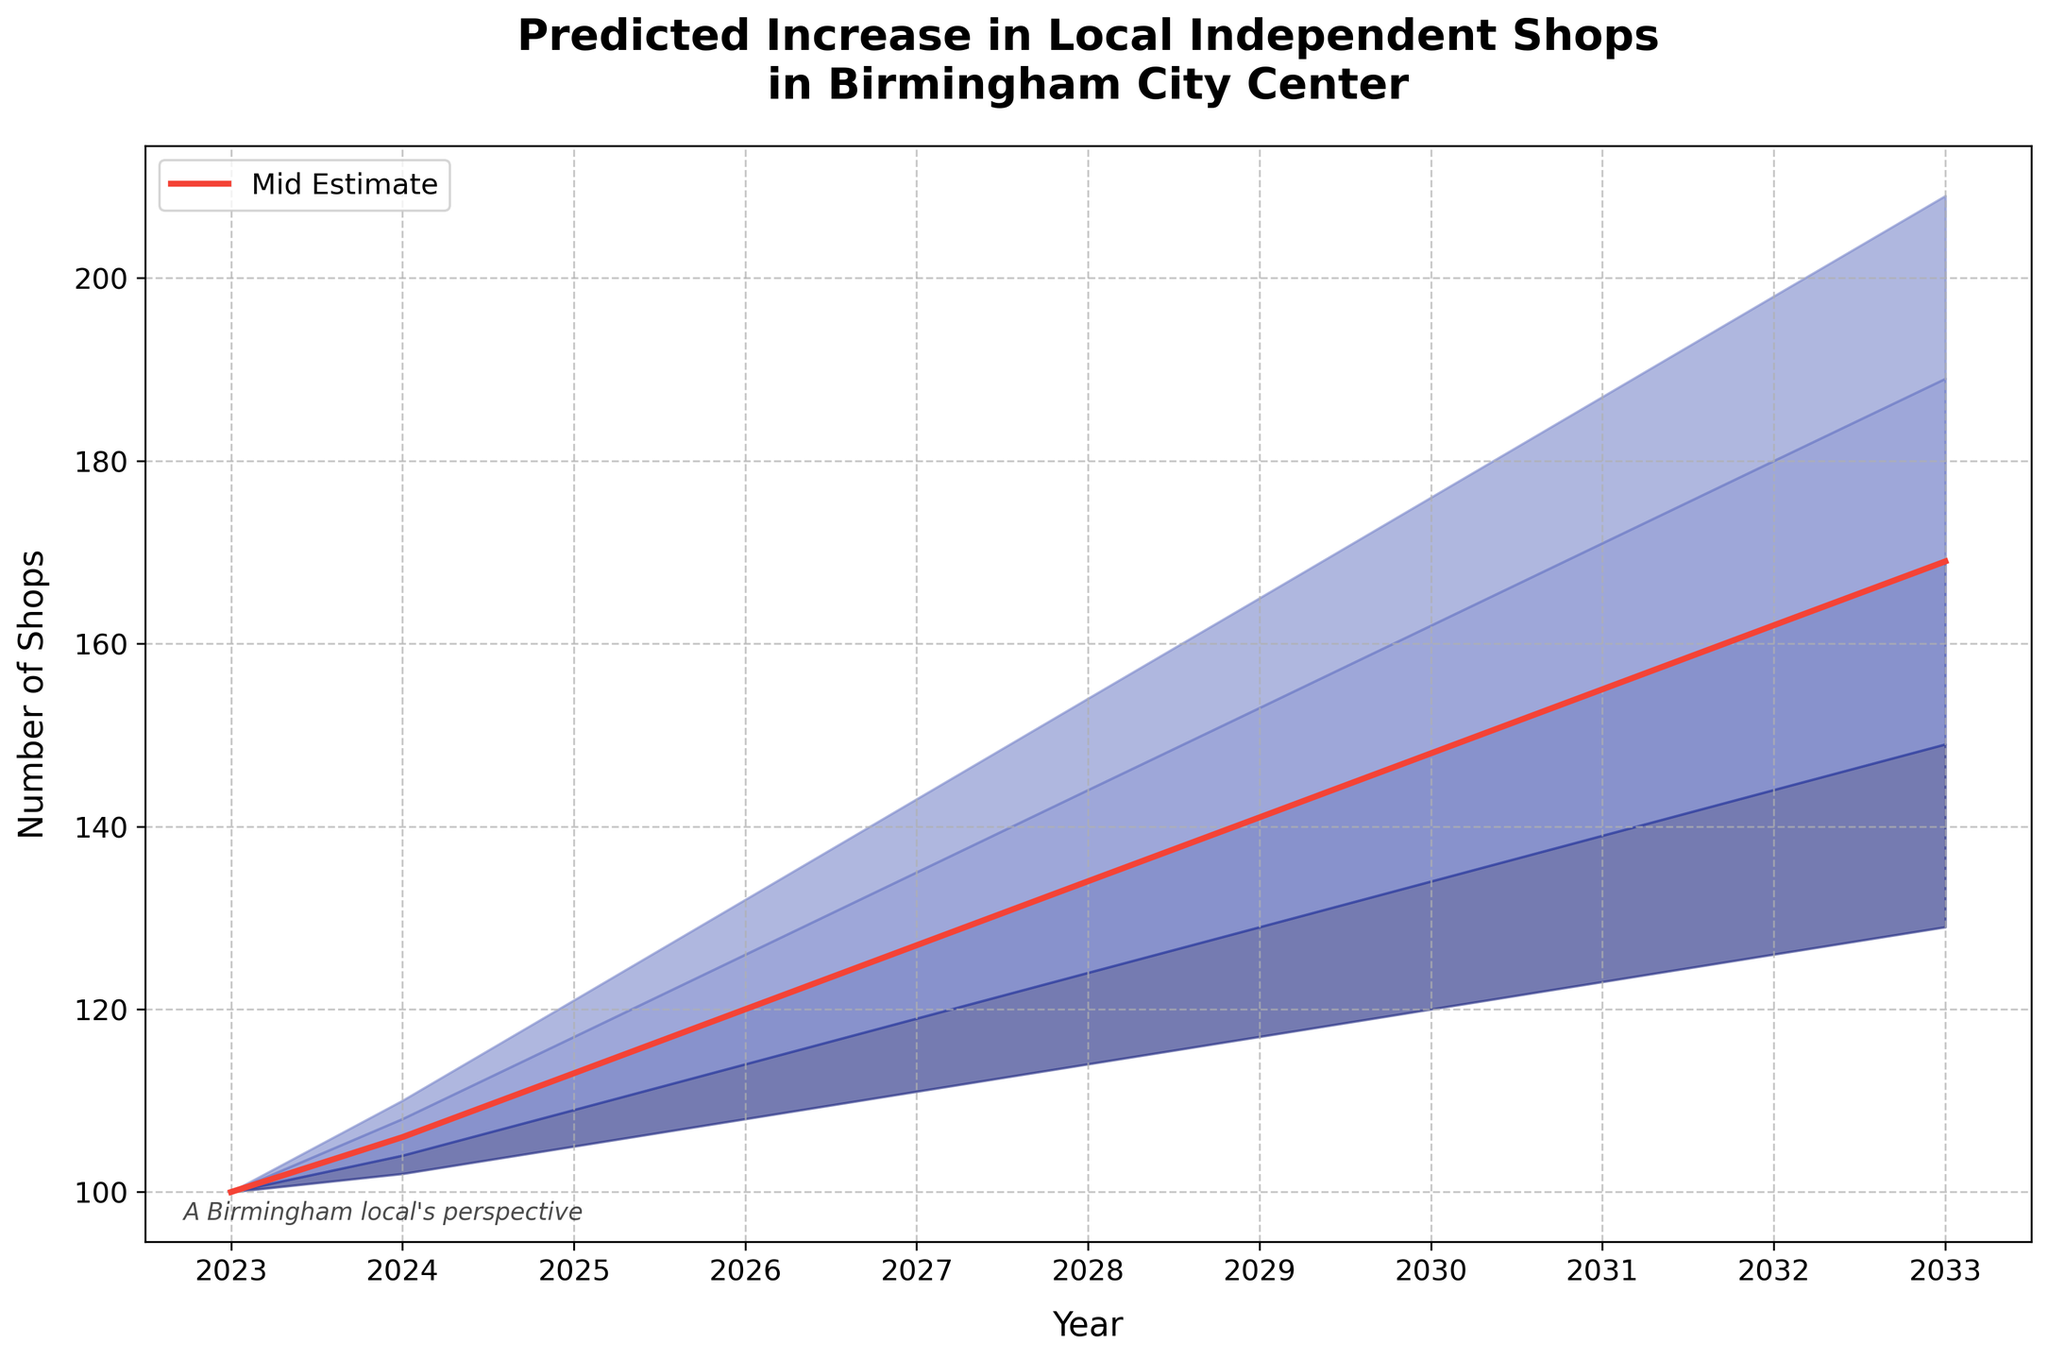What is the title of the chart? The title of the chart is located at the top and provides a summary of what the chart represents. This title reads, "Predicted Increase in Local Independent Shops in Birmingham City Center."
Answer: Predicted Increase in Local Independent Shops in Birmingham City Center In which year is the number of local independent shops expected to reach around 150 according to the Mid Estimate? By examining the Mid Estimate line (red line) and tracking its progression through the years, it intersects around the value of 150 in the year 2032.
Answer: 2032 What is the estimated range of local independent shops in 2025? To find the range, we look at the lowest (Low Estimate) and highest (High Estimate) boundaries for the year 2025. The Low Estimate is 105, and the High Estimate is 121. The range is therefore 121 - 105.
Answer: 16 shops By how much does the Mid Estimate of local independent shops increase from 2023 to 2033? The Mid Estimate starts at 100 shops in 2023 and reaches 169 shops in 2033. The increase is calculated by subtracting the initial value from the final value: 169 - 100.
Answer: 69 shops Which year has the smallest increase in the High Estimate of local independent shops compared to the previous year? Comparing annual High Estimate increases, the smallest difference occurs from 2027 to 2028. The increase from 2027 to 2028 is 154 - 143 = 11 shops, which is less than other years.
Answer: 2028 What color is used to represent the Mid Estimate line? The Mid Estimate line is represented with a distinct color that is clearly mentioned in the figure's legend. This line is shown in a bright red color.
Answer: Red How does the number of shops projected in the High Estimate for 2030 compare to the number projected in the Low Estimate for the same year? In 2030, the High Estimate projects 176 shops, while the Low Estimate projects 120 shops. The difference between them is 176 - 120.
Answer: 56 shops What is the general trend in the number of local independent shops from 2023 to 2033 according to all estimates? Observing all the estimate regions, which include Low, Low-Mid, Mid, Mid-High, and High, they all show an increasing trend in the number of local independent shops over the years from 2023 to 2033. This suggests a consistent predicted growth.
Answer: Increasing trend Between which years does the Mid Estimate of local independent shops exhibit the highest annual increase? By examining the slope of the Mid Estimate line, the highest annual increase is between 2023 to 2024 with a slope of (106-100) being the highest initial jump.
Answer: 2023 to 2024 What annotation is added to the figure to reflect the view of a Birmingham local? In the bottom left corner of the figure, there is a text annotation that states “A Birmingham local's perspective.” This provides additional context about the view being represented.
Answer: A Birmingham local's perspective 